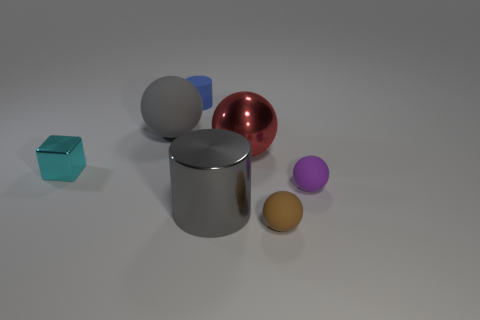Subtract all rubber spheres. How many spheres are left? 1 Subtract all cylinders. How many objects are left? 5 Subtract 2 balls. How many balls are left? 2 Subtract all purple balls. Subtract all purple cubes. How many balls are left? 3 Subtract all green blocks. How many gray cylinders are left? 1 Subtract all balls. Subtract all green balls. How many objects are left? 3 Add 6 big gray cylinders. How many big gray cylinders are left? 7 Add 4 small purple spheres. How many small purple spheres exist? 5 Add 3 brown objects. How many objects exist? 10 Subtract all red balls. How many balls are left? 3 